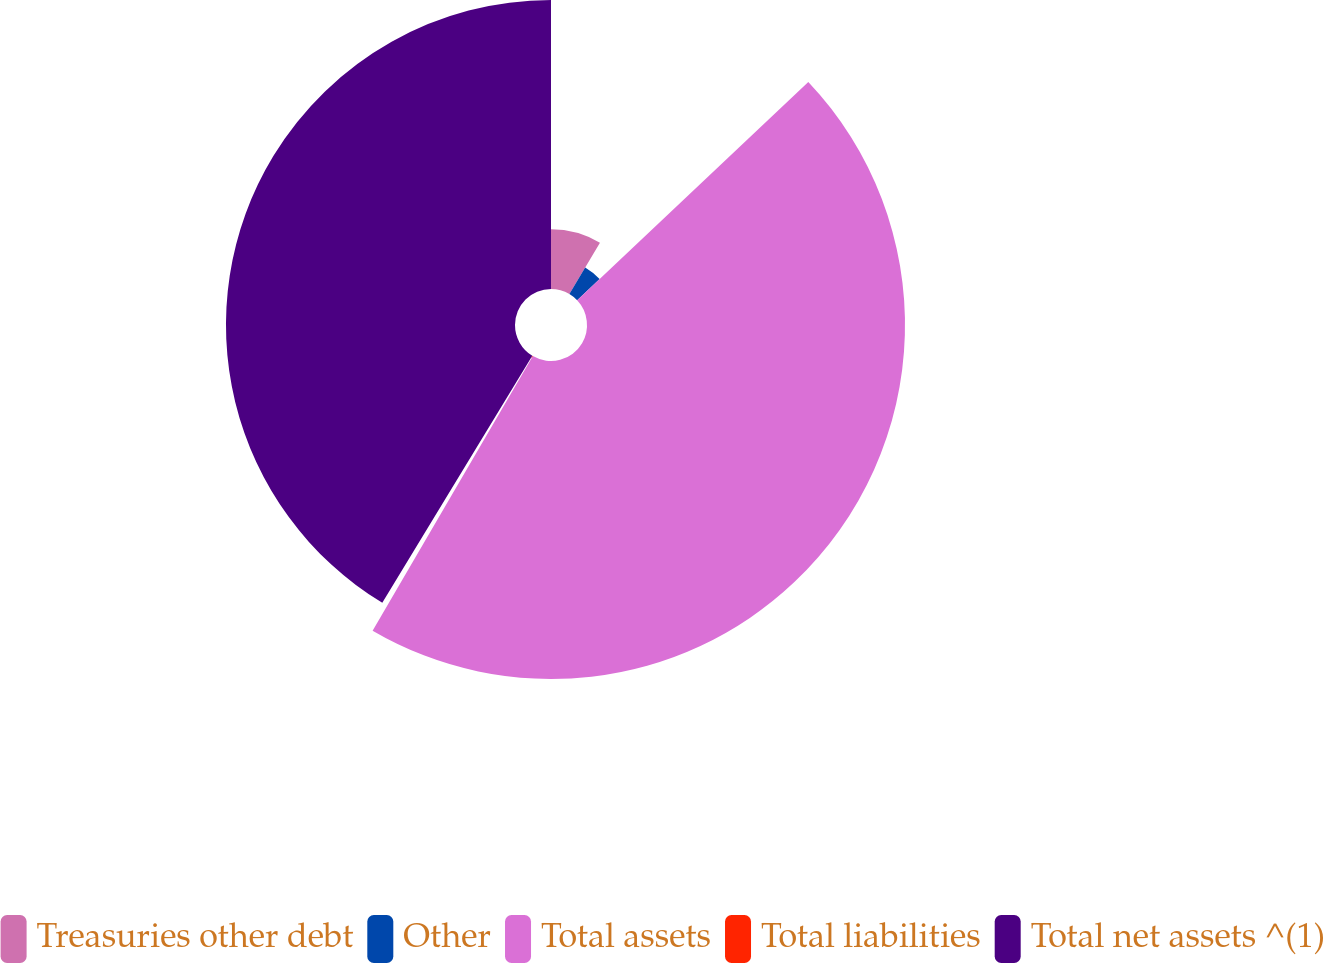Convert chart to OTSL. <chart><loc_0><loc_0><loc_500><loc_500><pie_chart><fcel>Treasuries other debt<fcel>Other<fcel>Total assets<fcel>Total liabilities<fcel>Total net assets ^(1)<nl><fcel>8.54%<fcel>4.41%<fcel>45.45%<fcel>0.28%<fcel>41.31%<nl></chart> 